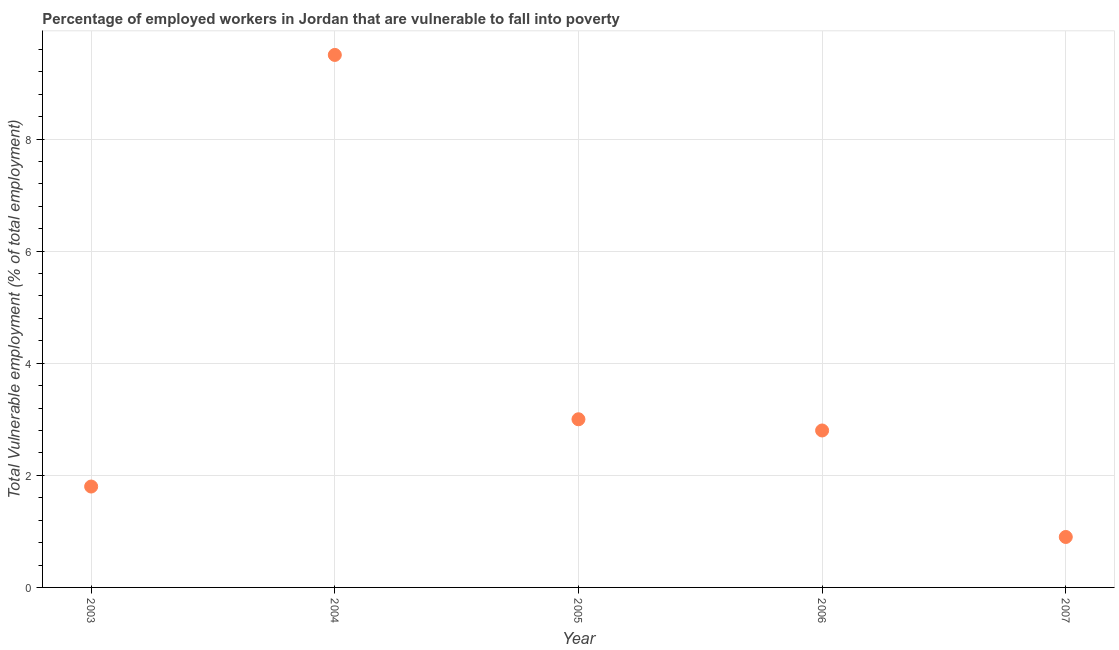What is the total vulnerable employment in 2003?
Provide a succinct answer. 1.8. Across all years, what is the maximum total vulnerable employment?
Offer a very short reply. 9.5. Across all years, what is the minimum total vulnerable employment?
Offer a very short reply. 0.9. What is the sum of the total vulnerable employment?
Offer a terse response. 18. What is the difference between the total vulnerable employment in 2004 and 2007?
Offer a very short reply. 8.6. What is the average total vulnerable employment per year?
Provide a succinct answer. 3.6. What is the median total vulnerable employment?
Provide a succinct answer. 2.8. Do a majority of the years between 2004 and 2007 (inclusive) have total vulnerable employment greater than 8 %?
Provide a succinct answer. No. What is the ratio of the total vulnerable employment in 2006 to that in 2007?
Make the answer very short. 3.11. Is the difference between the total vulnerable employment in 2005 and 2007 greater than the difference between any two years?
Your response must be concise. No. Is the sum of the total vulnerable employment in 2005 and 2007 greater than the maximum total vulnerable employment across all years?
Offer a terse response. No. What is the difference between the highest and the lowest total vulnerable employment?
Make the answer very short. 8.6. How many dotlines are there?
Give a very brief answer. 1. How many years are there in the graph?
Make the answer very short. 5. Are the values on the major ticks of Y-axis written in scientific E-notation?
Ensure brevity in your answer.  No. Does the graph contain any zero values?
Make the answer very short. No. What is the title of the graph?
Give a very brief answer. Percentage of employed workers in Jordan that are vulnerable to fall into poverty. What is the label or title of the X-axis?
Provide a short and direct response. Year. What is the label or title of the Y-axis?
Offer a terse response. Total Vulnerable employment (% of total employment). What is the Total Vulnerable employment (% of total employment) in 2003?
Provide a succinct answer. 1.8. What is the Total Vulnerable employment (% of total employment) in 2004?
Ensure brevity in your answer.  9.5. What is the Total Vulnerable employment (% of total employment) in 2005?
Your response must be concise. 3. What is the Total Vulnerable employment (% of total employment) in 2006?
Offer a terse response. 2.8. What is the Total Vulnerable employment (% of total employment) in 2007?
Provide a succinct answer. 0.9. What is the difference between the Total Vulnerable employment (% of total employment) in 2003 and 2004?
Offer a terse response. -7.7. What is the difference between the Total Vulnerable employment (% of total employment) in 2003 and 2005?
Provide a succinct answer. -1.2. What is the difference between the Total Vulnerable employment (% of total employment) in 2003 and 2006?
Your response must be concise. -1. What is the difference between the Total Vulnerable employment (% of total employment) in 2003 and 2007?
Keep it short and to the point. 0.9. What is the difference between the Total Vulnerable employment (% of total employment) in 2004 and 2005?
Your response must be concise. 6.5. What is the difference between the Total Vulnerable employment (% of total employment) in 2005 and 2006?
Provide a short and direct response. 0.2. What is the difference between the Total Vulnerable employment (% of total employment) in 2005 and 2007?
Ensure brevity in your answer.  2.1. What is the difference between the Total Vulnerable employment (% of total employment) in 2006 and 2007?
Your answer should be very brief. 1.9. What is the ratio of the Total Vulnerable employment (% of total employment) in 2003 to that in 2004?
Your response must be concise. 0.19. What is the ratio of the Total Vulnerable employment (% of total employment) in 2003 to that in 2006?
Provide a succinct answer. 0.64. What is the ratio of the Total Vulnerable employment (% of total employment) in 2003 to that in 2007?
Your answer should be very brief. 2. What is the ratio of the Total Vulnerable employment (% of total employment) in 2004 to that in 2005?
Keep it short and to the point. 3.17. What is the ratio of the Total Vulnerable employment (% of total employment) in 2004 to that in 2006?
Your answer should be very brief. 3.39. What is the ratio of the Total Vulnerable employment (% of total employment) in 2004 to that in 2007?
Your response must be concise. 10.56. What is the ratio of the Total Vulnerable employment (% of total employment) in 2005 to that in 2006?
Provide a short and direct response. 1.07. What is the ratio of the Total Vulnerable employment (% of total employment) in 2005 to that in 2007?
Provide a succinct answer. 3.33. What is the ratio of the Total Vulnerable employment (% of total employment) in 2006 to that in 2007?
Offer a terse response. 3.11. 